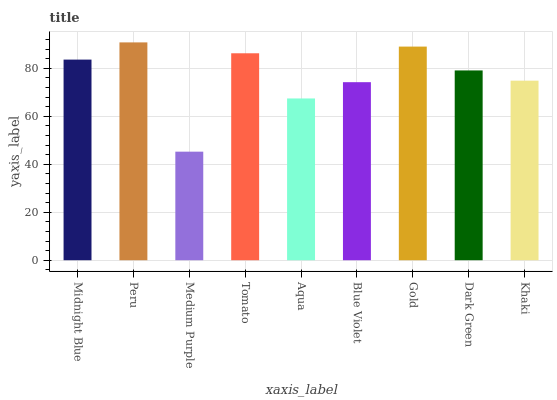Is Medium Purple the minimum?
Answer yes or no. Yes. Is Peru the maximum?
Answer yes or no. Yes. Is Peru the minimum?
Answer yes or no. No. Is Medium Purple the maximum?
Answer yes or no. No. Is Peru greater than Medium Purple?
Answer yes or no. Yes. Is Medium Purple less than Peru?
Answer yes or no. Yes. Is Medium Purple greater than Peru?
Answer yes or no. No. Is Peru less than Medium Purple?
Answer yes or no. No. Is Dark Green the high median?
Answer yes or no. Yes. Is Dark Green the low median?
Answer yes or no. Yes. Is Tomato the high median?
Answer yes or no. No. Is Peru the low median?
Answer yes or no. No. 